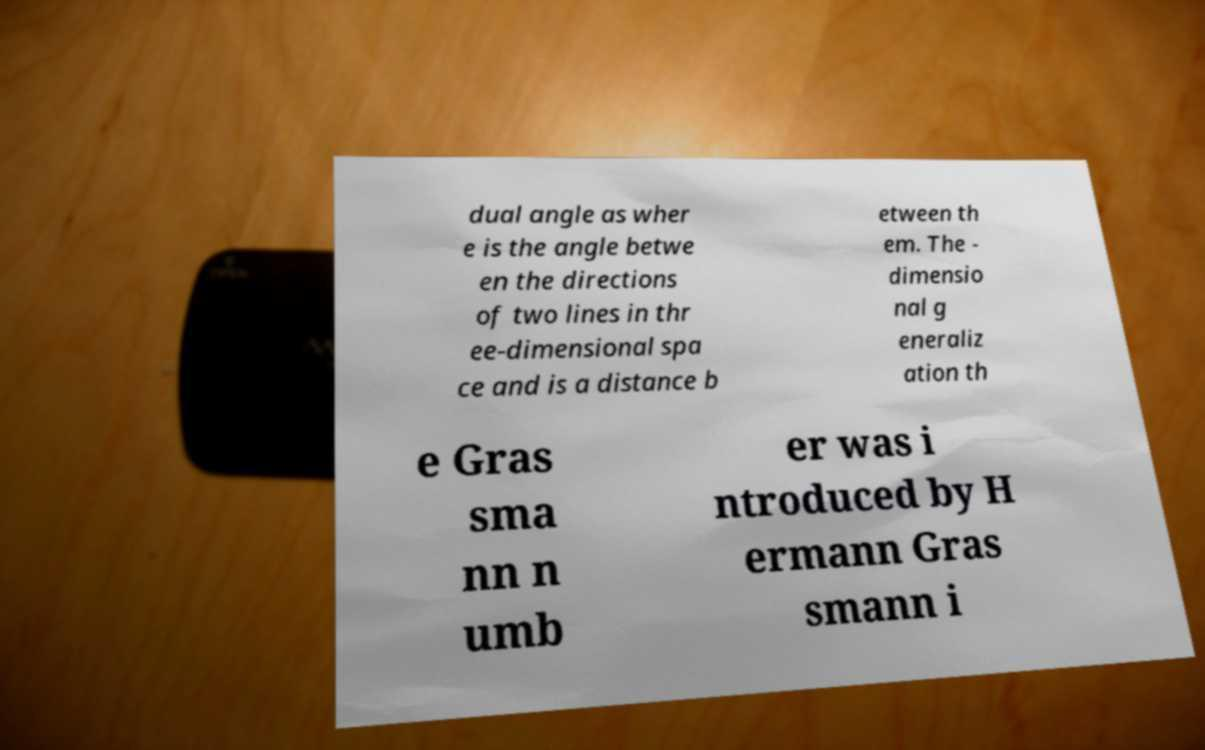Could you assist in decoding the text presented in this image and type it out clearly? dual angle as wher e is the angle betwe en the directions of two lines in thr ee-dimensional spa ce and is a distance b etween th em. The - dimensio nal g eneraliz ation th e Gras sma nn n umb er was i ntroduced by H ermann Gras smann i 